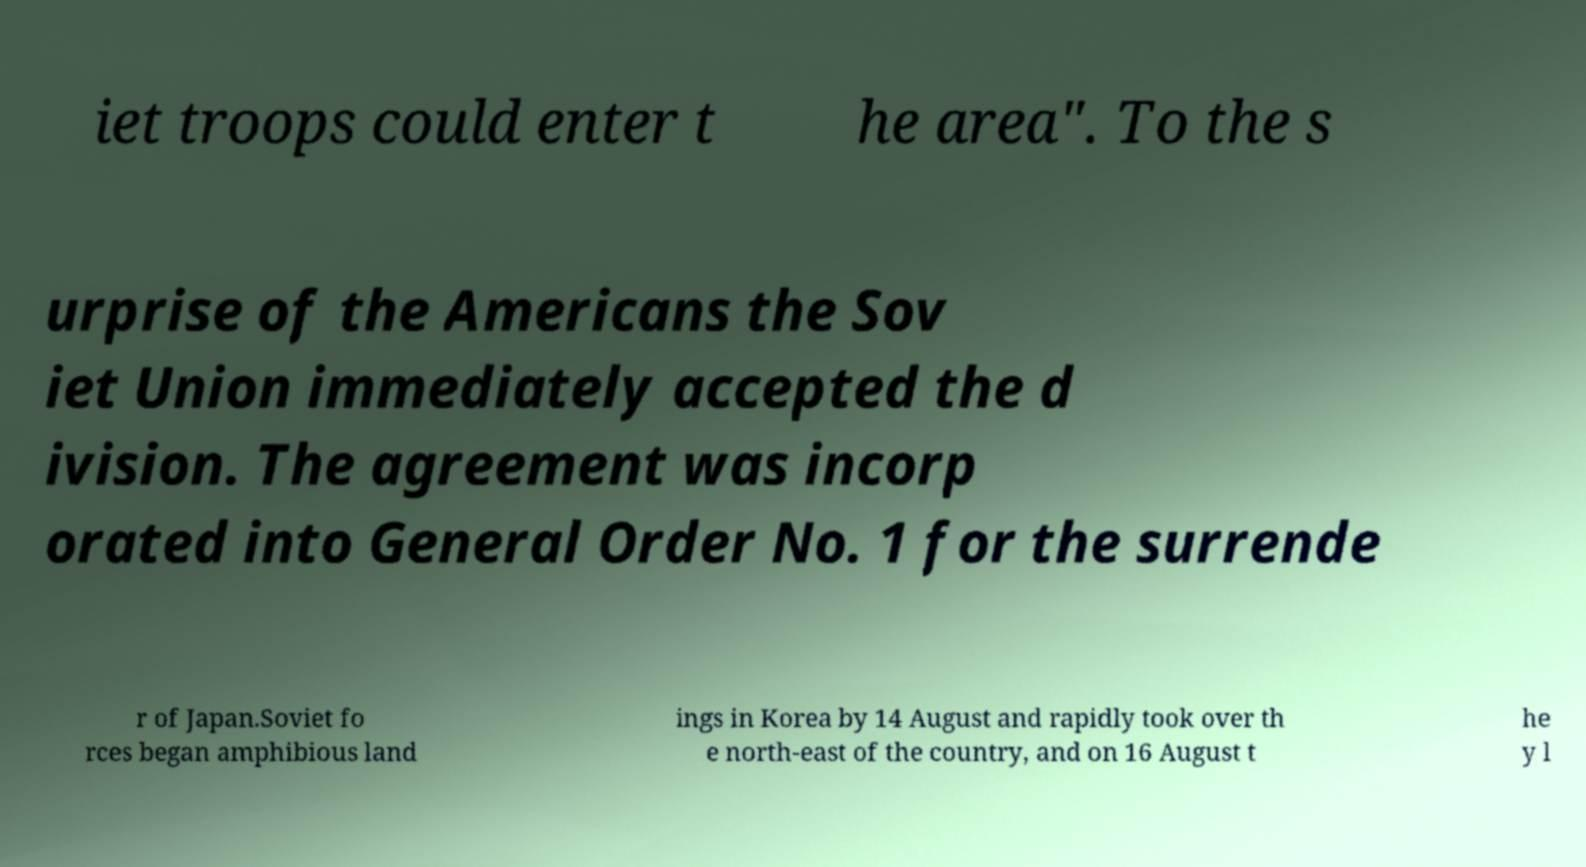What messages or text are displayed in this image? I need them in a readable, typed format. iet troops could enter t he area". To the s urprise of the Americans the Sov iet Union immediately accepted the d ivision. The agreement was incorp orated into General Order No. 1 for the surrende r of Japan.Soviet fo rces began amphibious land ings in Korea by 14 August and rapidly took over th e north-east of the country, and on 16 August t he y l 